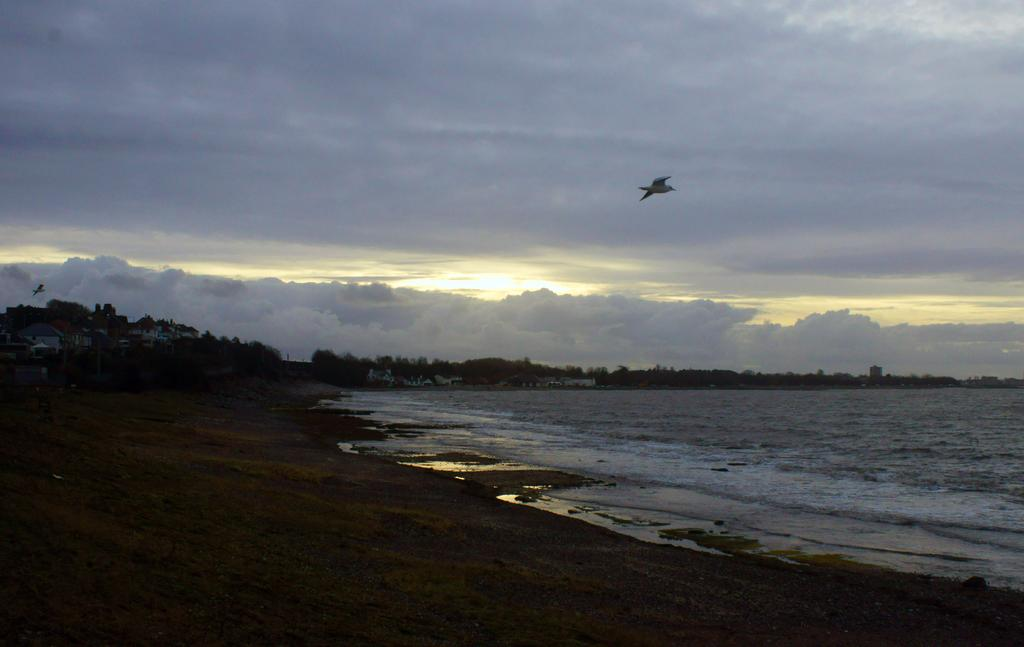What type of location is depicted in the image? There is a beach in the image. Are there any other natural features near the beach? Yes, there are trees near the beach. What can be seen in the sky above the beach? There are clouds visible in the sky. What type of animal is flying above the sea? There is a bird flying above the sea. Reasoning: Let' Let's think step by step in order to produce the conversation. We start by identifying the main location in the image, which is the beach. Then, we expand the conversation to include other natural features and elements that are also visible, such as trees, clouds, and the bird. Each question is designed to elicit a specific detail about the image that is known from the provided facts. Absurd Question/Answer: What is the name of the theory that explains the behavior of the bird in the image? There is no specific theory mentioned or implied in the image, as it simply shows a bird flying above the sea. 